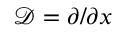Convert formula to latex. <formula><loc_0><loc_0><loc_500><loc_500>\mathcal { D } = \partial / \partial x</formula> 